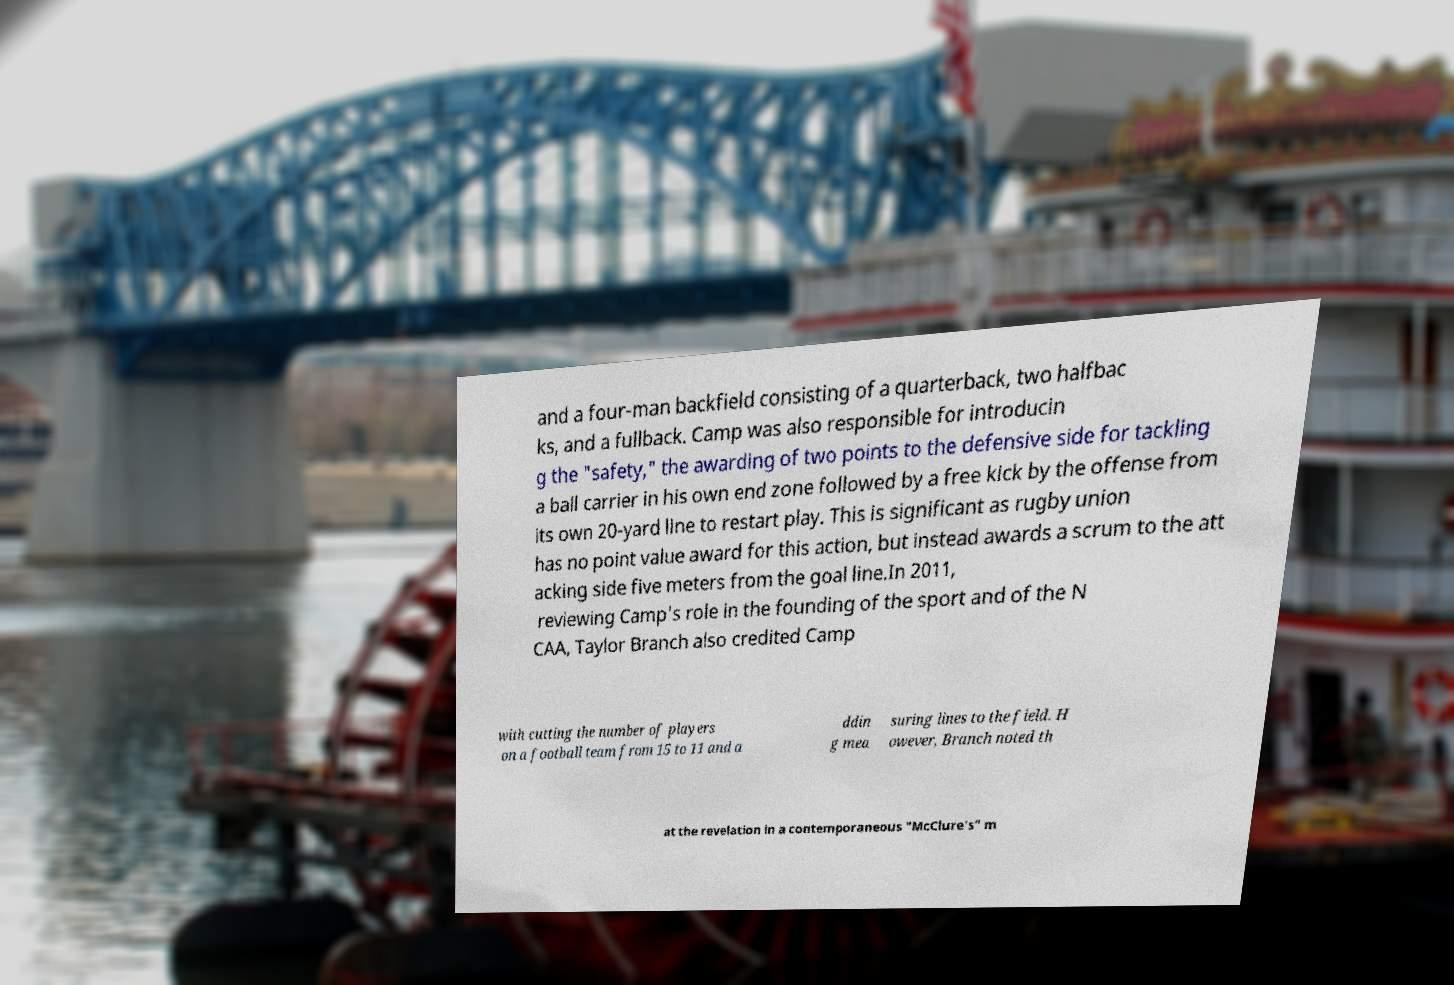Can you read and provide the text displayed in the image?This photo seems to have some interesting text. Can you extract and type it out for me? and a four-man backfield consisting of a quarterback, two halfbac ks, and a fullback. Camp was also responsible for introducin g the "safety," the awarding of two points to the defensive side for tackling a ball carrier in his own end zone followed by a free kick by the offense from its own 20-yard line to restart play. This is significant as rugby union has no point value award for this action, but instead awards a scrum to the att acking side five meters from the goal line.In 2011, reviewing Camp's role in the founding of the sport and of the N CAA, Taylor Branch also credited Camp with cutting the number of players on a football team from 15 to 11 and a ddin g mea suring lines to the field. H owever, Branch noted th at the revelation in a contemporaneous "McClure's" m 